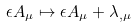<formula> <loc_0><loc_0><loc_500><loc_500>\epsilon A _ { \mu } \mapsto \epsilon A _ { \mu } + \lambda _ { , \mu }</formula> 